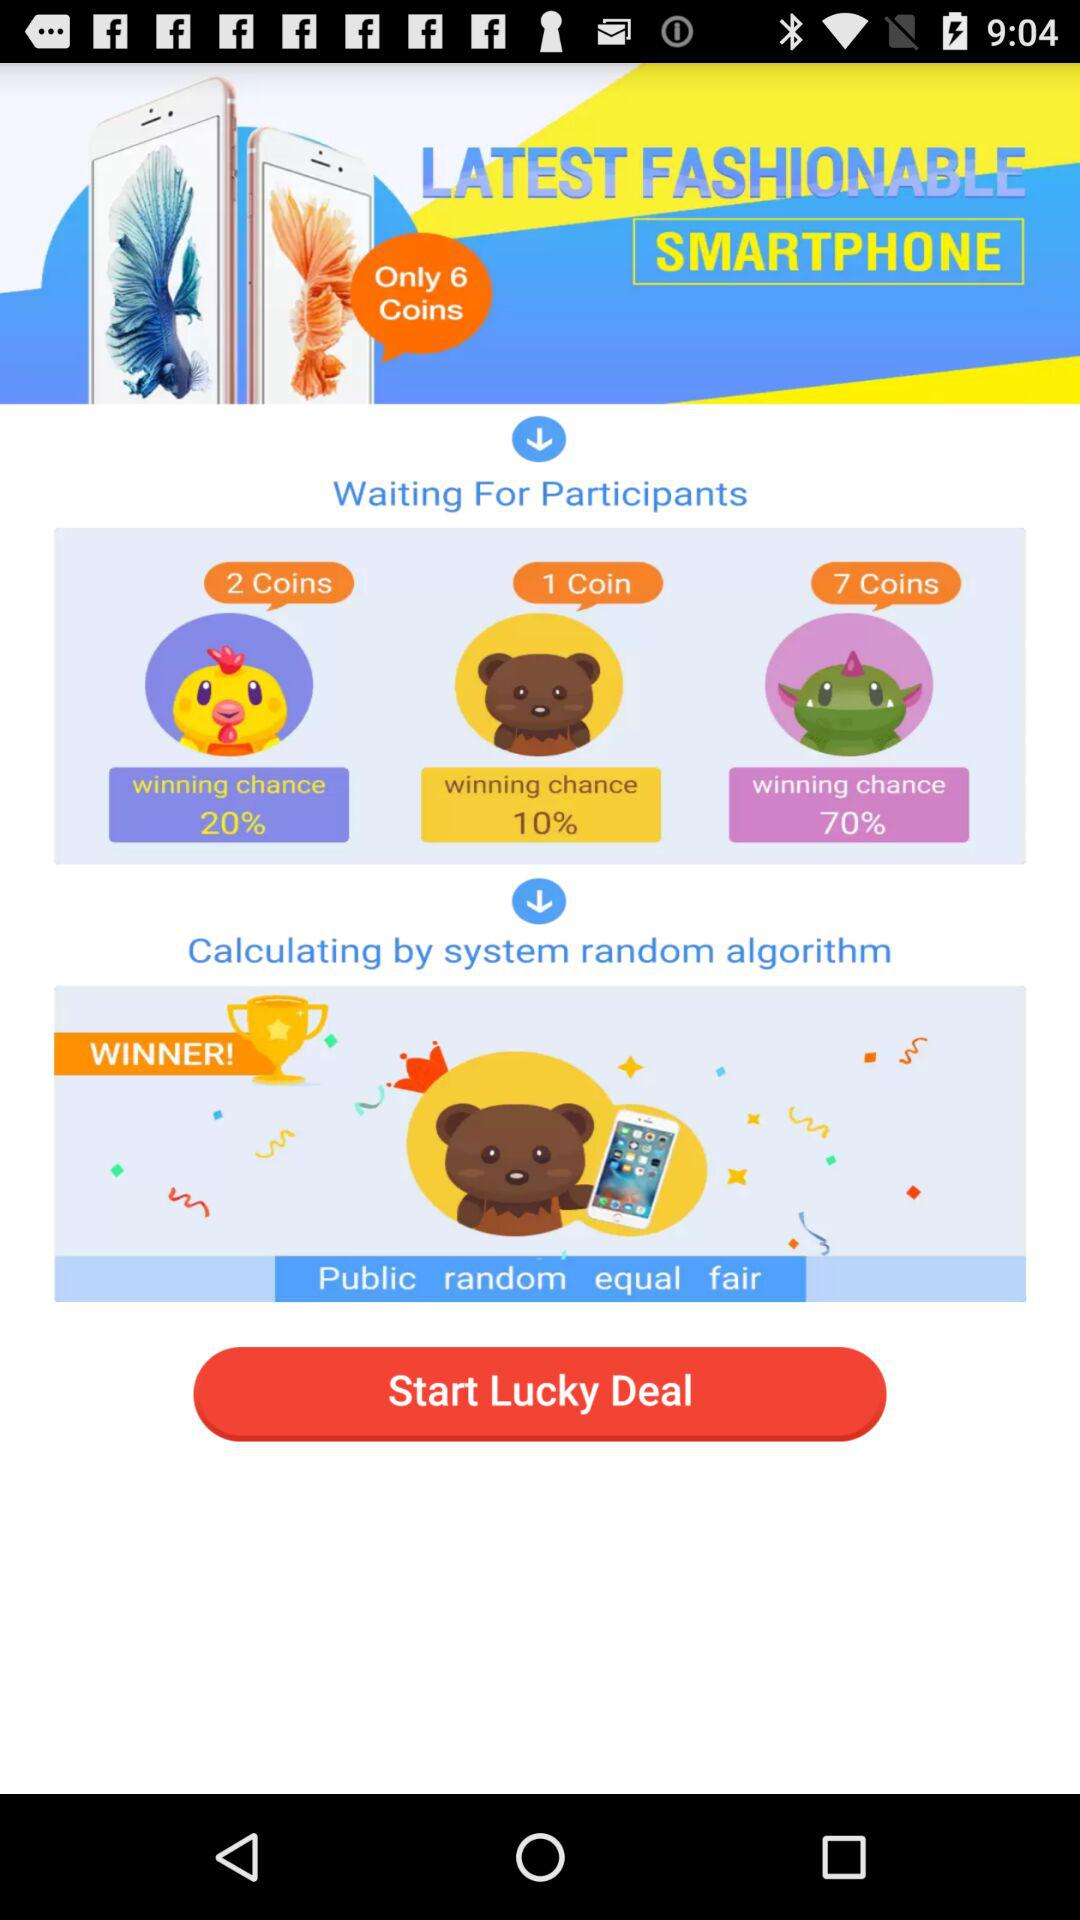How many coins are required for the lowest winning chance?
Answer the question using a single word or phrase. 1 